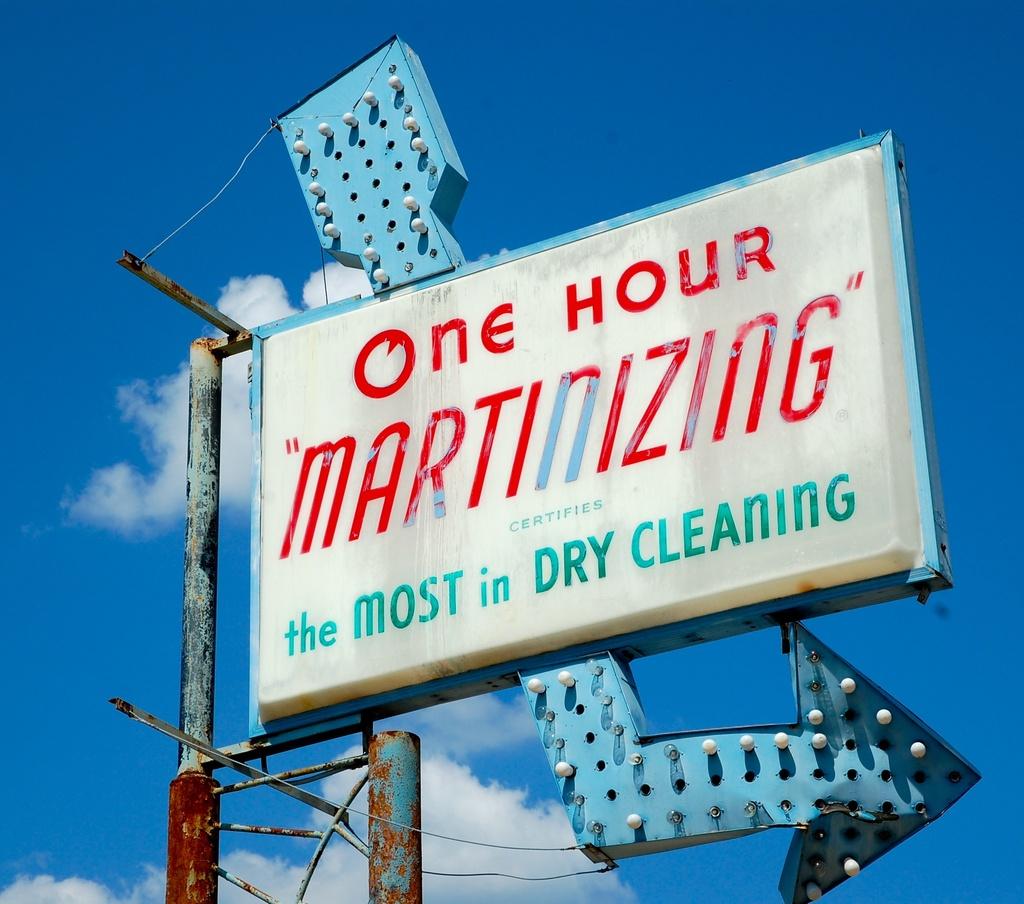What is the billboard advertising?
Offer a very short reply. Dry cleaning. Does this advertise the most in dry cleaning?
Provide a short and direct response. Yes. 